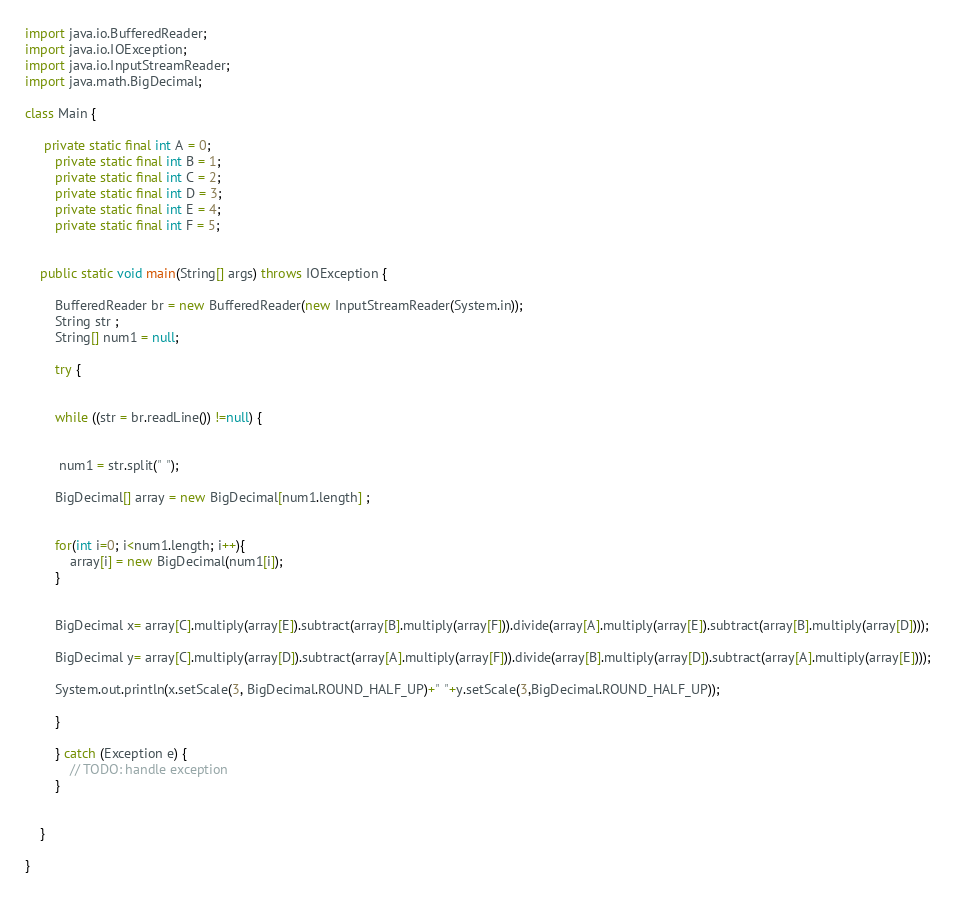<code> <loc_0><loc_0><loc_500><loc_500><_Java_>import java.io.BufferedReader;
import java.io.IOException;
import java.io.InputStreamReader;
import java.math.BigDecimal;

class Main {

	 private static final int A = 0;
	    private static final int B = 1;
	    private static final int C = 2;
	    private static final int D = 3;
	    private static final int E = 4;
	    private static final int F = 5;


	public static void main(String[] args) throws IOException {

		BufferedReader br = new BufferedReader(new InputStreamReader(System.in));
		String str ;
		String[] num1 = null;

		try {


		while ((str = br.readLine()) !=null) {


		 num1 = str.split(" ");

		BigDecimal[] array = new BigDecimal[num1.length] ;


		for(int i=0; i<num1.length; i++){
			array[i] = new BigDecimal(num1[i]);
		}


		BigDecimal x= array[C].multiply(array[E]).subtract(array[B].multiply(array[F])).divide(array[A].multiply(array[E]).subtract(array[B].multiply(array[D])));

		BigDecimal y= array[C].multiply(array[D]).subtract(array[A].multiply(array[F])).divide(array[B].multiply(array[D]).subtract(array[A].multiply(array[E])));

		System.out.println(x.setScale(3, BigDecimal.ROUND_HALF_UP)+" "+y.setScale(3,BigDecimal.ROUND_HALF_UP));

		}

		} catch (Exception e) {
			// TODO: handle exception
		}


	}

}</code> 